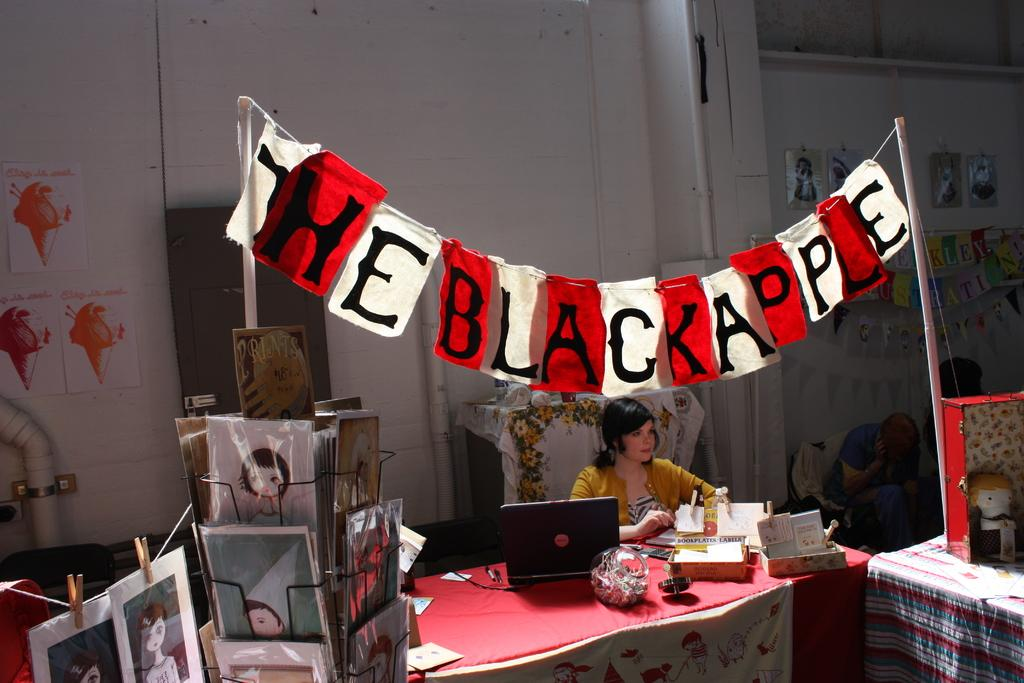What is the person in the image doing? There is a person sitting in the image. What is on the table in the image? A laptop, a box, and papers are visible on the table. What is the purpose of the banner in the image? The banner is attached to two poles in the image, but the purpose is not specified. What can be seen in the background of the image? There is a wall and posters in the background of the image. How does the person in the image expand the alley? There is no alley present in the image, and the person is not shown expanding anything. 